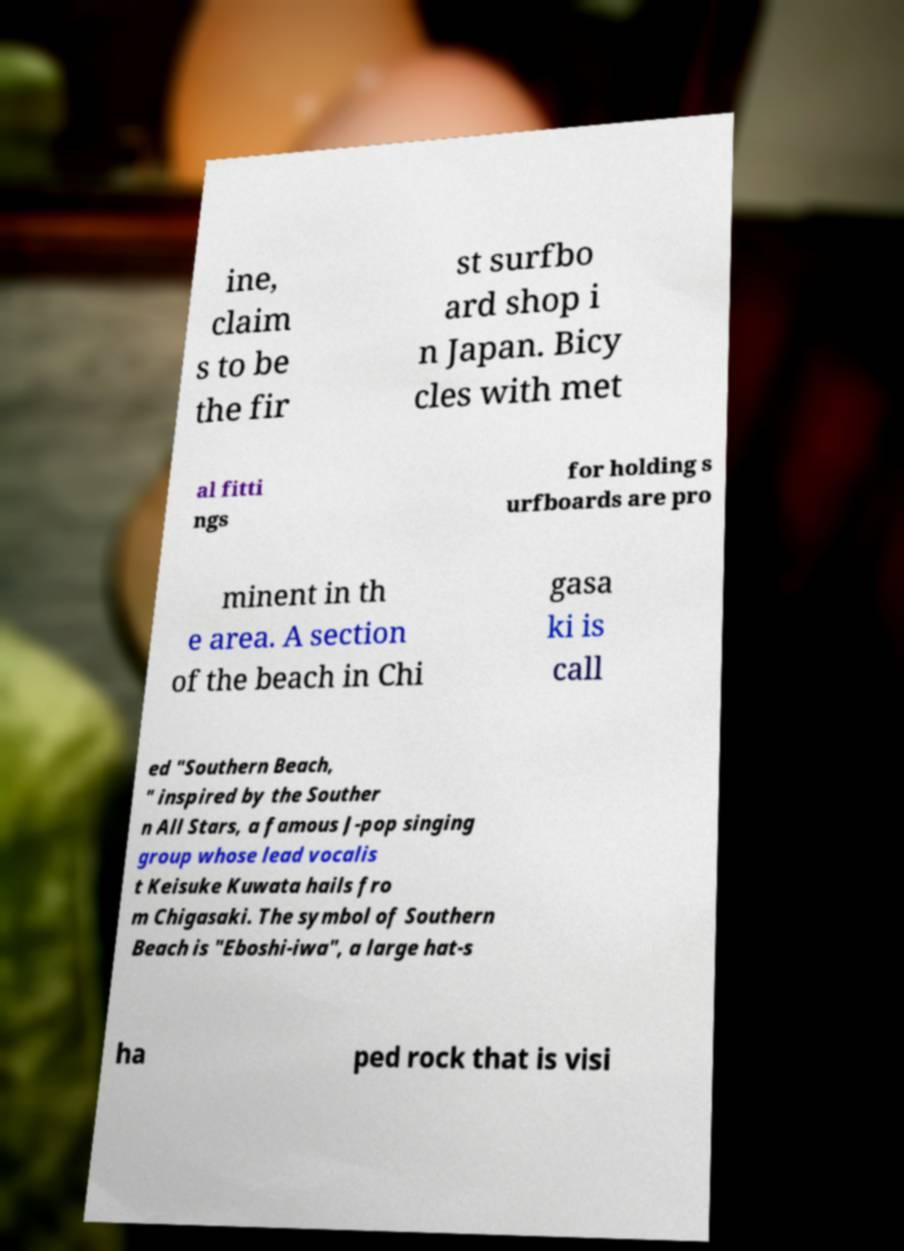For documentation purposes, I need the text within this image transcribed. Could you provide that? ine, claim s to be the fir st surfbo ard shop i n Japan. Bicy cles with met al fitti ngs for holding s urfboards are pro minent in th e area. A section of the beach in Chi gasa ki is call ed "Southern Beach, " inspired by the Souther n All Stars, a famous J-pop singing group whose lead vocalis t Keisuke Kuwata hails fro m Chigasaki. The symbol of Southern Beach is "Eboshi-iwa", a large hat-s ha ped rock that is visi 